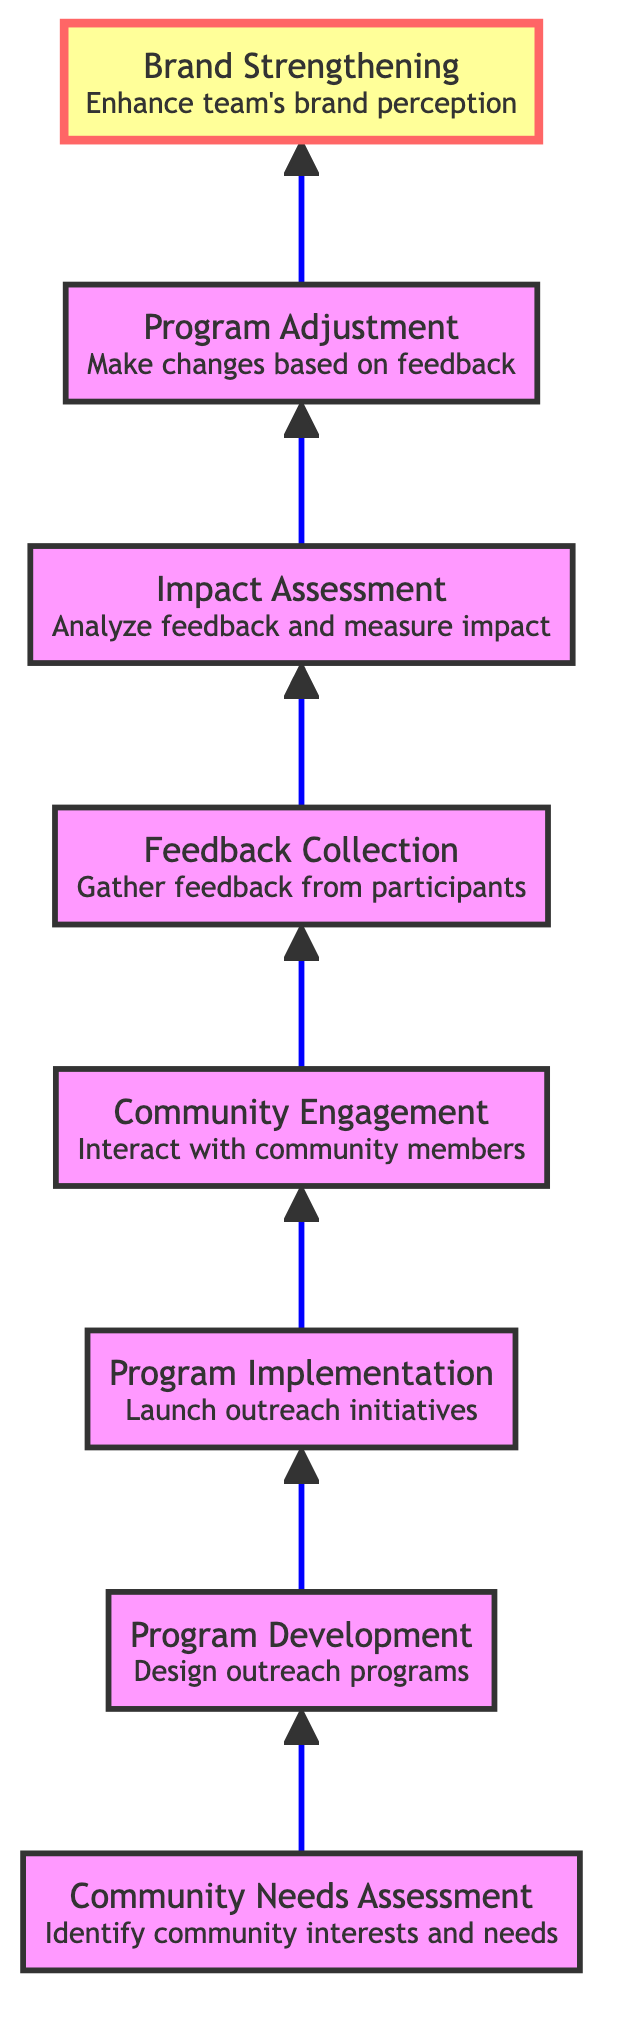What is the first step in the diagram? The diagram starts with the "Community Needs Assessment" node, which is the first element in the flowchart.
Answer: Community Needs Assessment How many nodes are in the diagram? The diagram has a total of eight distinct nodes representing different stages of the outreach programs and feedback loops.
Answer: Eight What follows "Program Implementation"? According to the flow of the diagram, "Community Engagement" follows "Program Implementation," indicating the next step in the process.
Answer: Community Engagement What is required for "Impact Assessment"? "Impact Assessment" requires feedback that is gathered in the previous step, which is "Feedback Collection."
Answer: Feedback Collection How does the "Program Adjustment" affect "Brand Strengthening"? "Program Adjustment" makes changes based on feedback collected from participants, which ultimately enhances "Brand Strengthening" if effective adjustments are made.
Answer: Enhances What connects "Feedback Collection" and "Impact Assessment"? The connection between "Feedback Collection" and "Impact Assessment" indicates that collected feedback is analyzed for measuring the impact of the outreach programs.
Answer: Analyzed feedback Which node represents the most critical point for determining program changes? The "Program Adjustment" node is crucial since it directly responds to the feedback and impact assessment, indicating changes to be made for future initiatives.
Answer: Program Adjustment How many steps lead to "Brand Strengthening"? There are six steps leading to "Brand Strengthening," which illustrates the process from initial assessment to enhancing brand perception through outreach initiatives.
Answer: Six 